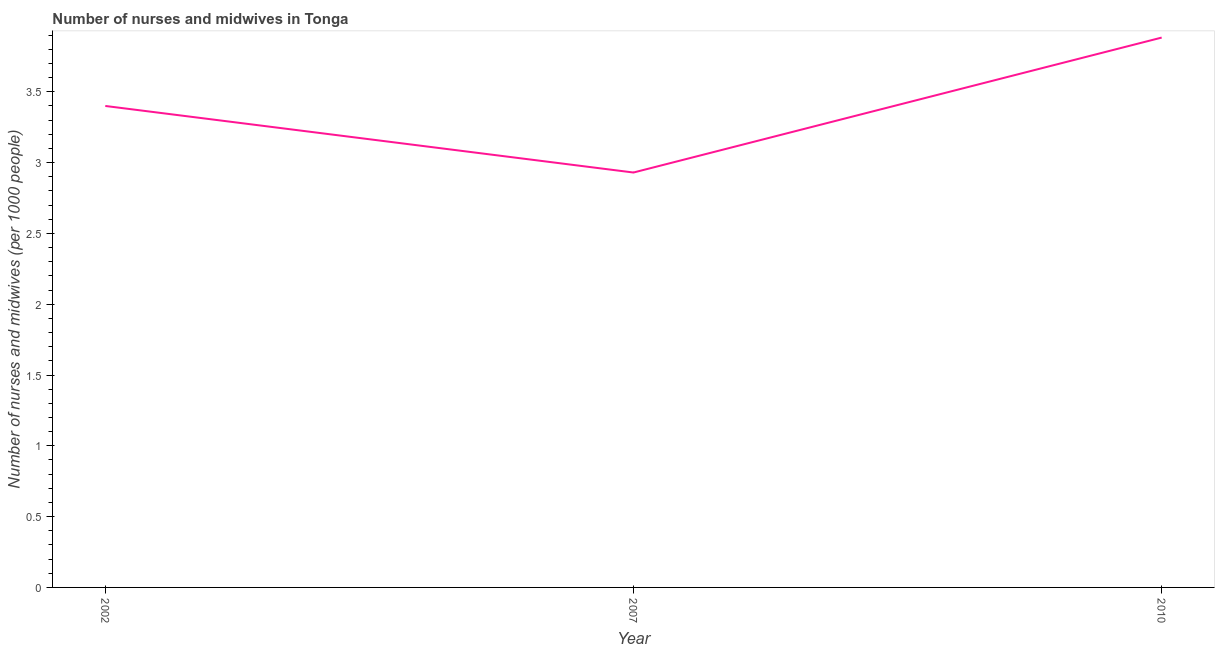What is the number of nurses and midwives in 2002?
Make the answer very short. 3.4. Across all years, what is the maximum number of nurses and midwives?
Make the answer very short. 3.88. Across all years, what is the minimum number of nurses and midwives?
Offer a terse response. 2.93. What is the sum of the number of nurses and midwives?
Your answer should be compact. 10.21. What is the difference between the number of nurses and midwives in 2002 and 2010?
Ensure brevity in your answer.  -0.48. What is the average number of nurses and midwives per year?
Your answer should be compact. 3.4. What is the ratio of the number of nurses and midwives in 2002 to that in 2007?
Give a very brief answer. 1.16. Is the difference between the number of nurses and midwives in 2007 and 2010 greater than the difference between any two years?
Your answer should be very brief. Yes. What is the difference between the highest and the second highest number of nurses and midwives?
Keep it short and to the point. 0.48. What is the difference between the highest and the lowest number of nurses and midwives?
Offer a very short reply. 0.95. How many years are there in the graph?
Ensure brevity in your answer.  3. What is the difference between two consecutive major ticks on the Y-axis?
Offer a very short reply. 0.5. Are the values on the major ticks of Y-axis written in scientific E-notation?
Make the answer very short. No. Does the graph contain any zero values?
Your answer should be very brief. No. What is the title of the graph?
Your response must be concise. Number of nurses and midwives in Tonga. What is the label or title of the Y-axis?
Ensure brevity in your answer.  Number of nurses and midwives (per 1000 people). What is the Number of nurses and midwives (per 1000 people) in 2007?
Your response must be concise. 2.93. What is the Number of nurses and midwives (per 1000 people) in 2010?
Your answer should be very brief. 3.88. What is the difference between the Number of nurses and midwives (per 1000 people) in 2002 and 2007?
Your answer should be compact. 0.47. What is the difference between the Number of nurses and midwives (per 1000 people) in 2002 and 2010?
Offer a very short reply. -0.48. What is the difference between the Number of nurses and midwives (per 1000 people) in 2007 and 2010?
Provide a succinct answer. -0.95. What is the ratio of the Number of nurses and midwives (per 1000 people) in 2002 to that in 2007?
Your answer should be very brief. 1.16. What is the ratio of the Number of nurses and midwives (per 1000 people) in 2002 to that in 2010?
Ensure brevity in your answer.  0.88. What is the ratio of the Number of nurses and midwives (per 1000 people) in 2007 to that in 2010?
Give a very brief answer. 0.76. 